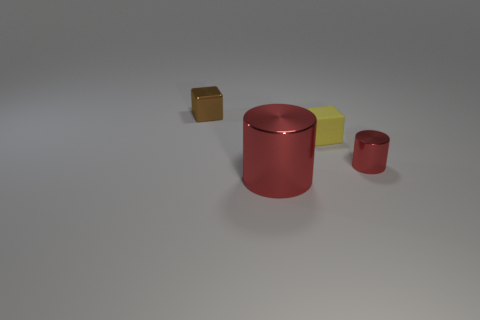Add 1 small yellow matte things. How many objects exist? 5 Subtract all yellow cubes. How many cubes are left? 1 Add 3 red metallic cylinders. How many red metallic cylinders exist? 5 Subtract 0 purple cylinders. How many objects are left? 4 Subtract 1 blocks. How many blocks are left? 1 Subtract all cyan cylinders. Subtract all red blocks. How many cylinders are left? 2 Subtract all cyan spheres. How many brown blocks are left? 1 Subtract all tiny red cylinders. Subtract all small rubber things. How many objects are left? 2 Add 2 tiny metallic cylinders. How many tiny metallic cylinders are left? 3 